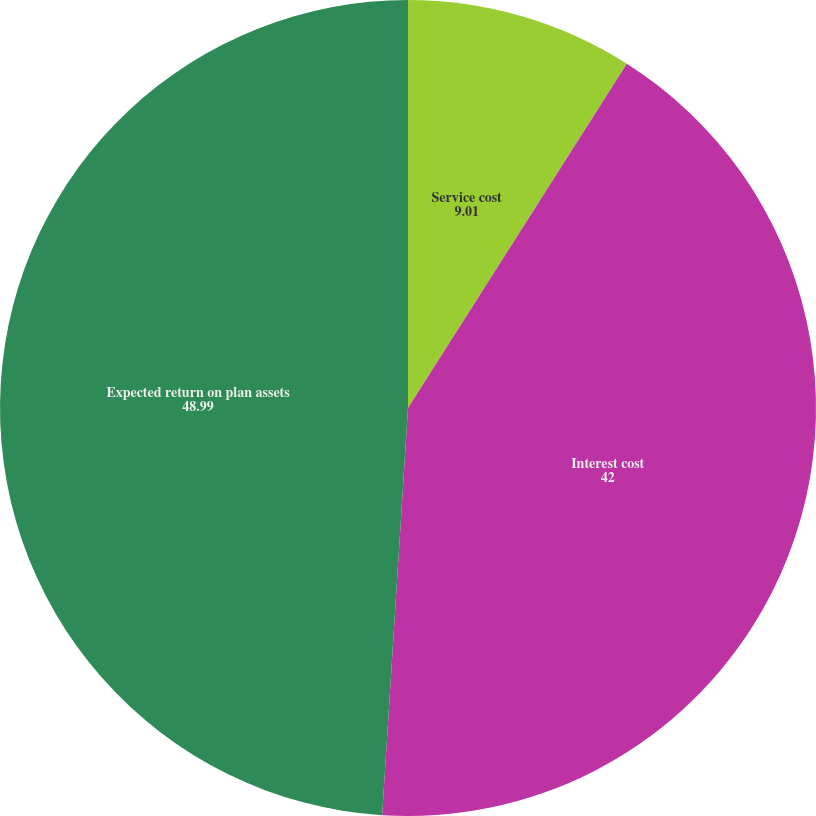Convert chart to OTSL. <chart><loc_0><loc_0><loc_500><loc_500><pie_chart><fcel>Service cost<fcel>Interest cost<fcel>Expected return on plan assets<nl><fcel>9.01%<fcel>42.0%<fcel>48.99%<nl></chart> 